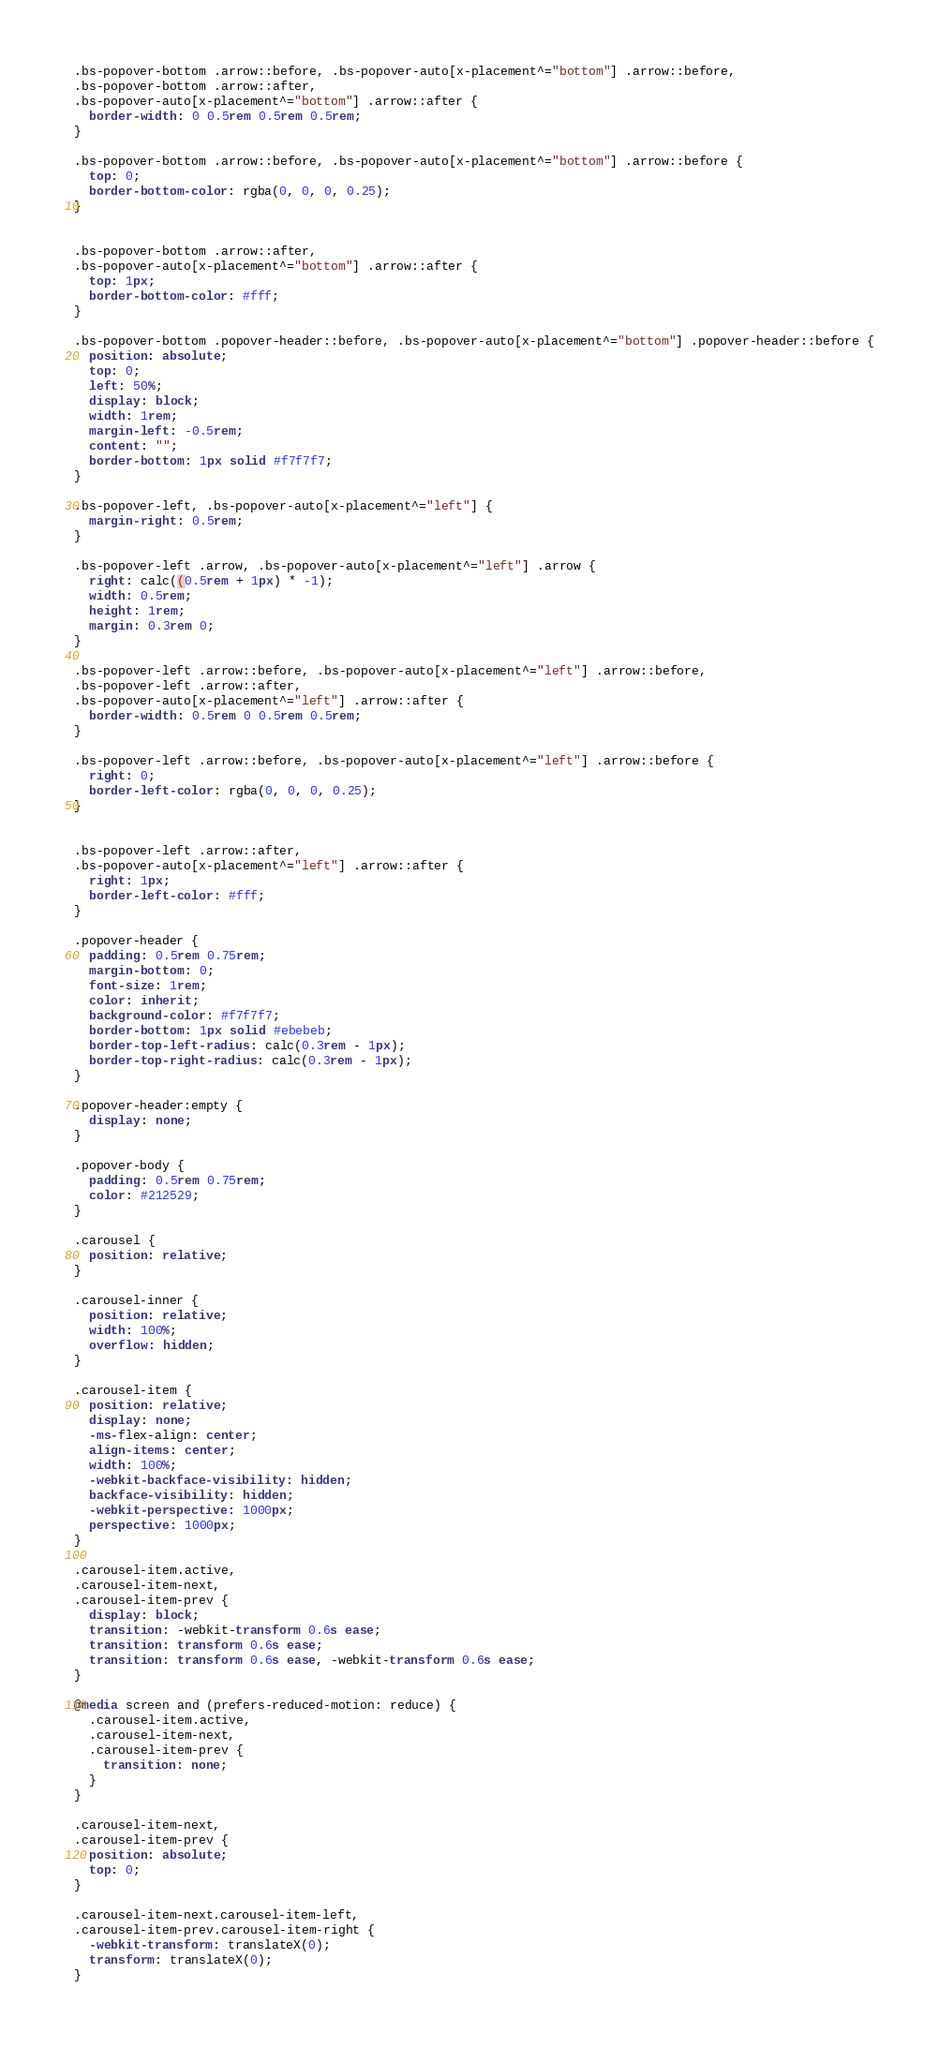Convert code to text. <code><loc_0><loc_0><loc_500><loc_500><_CSS_>
.bs-popover-bottom .arrow::before, .bs-popover-auto[x-placement^="bottom"] .arrow::before,
.bs-popover-bottom .arrow::after,
.bs-popover-auto[x-placement^="bottom"] .arrow::after {
  border-width: 0 0.5rem 0.5rem 0.5rem;
}

.bs-popover-bottom .arrow::before, .bs-popover-auto[x-placement^="bottom"] .arrow::before {
  top: 0;
  border-bottom-color: rgba(0, 0, 0, 0.25);
}


.bs-popover-bottom .arrow::after,
.bs-popover-auto[x-placement^="bottom"] .arrow::after {
  top: 1px;
  border-bottom-color: #fff;
}

.bs-popover-bottom .popover-header::before, .bs-popover-auto[x-placement^="bottom"] .popover-header::before {
  position: absolute;
  top: 0;
  left: 50%;
  display: block;
  width: 1rem;
  margin-left: -0.5rem;
  content: "";
  border-bottom: 1px solid #f7f7f7;
}

.bs-popover-left, .bs-popover-auto[x-placement^="left"] {
  margin-right: 0.5rem;
}

.bs-popover-left .arrow, .bs-popover-auto[x-placement^="left"] .arrow {
  right: calc((0.5rem + 1px) * -1);
  width: 0.5rem;
  height: 1rem;
  margin: 0.3rem 0;
}

.bs-popover-left .arrow::before, .bs-popover-auto[x-placement^="left"] .arrow::before,
.bs-popover-left .arrow::after,
.bs-popover-auto[x-placement^="left"] .arrow::after {
  border-width: 0.5rem 0 0.5rem 0.5rem;
}

.bs-popover-left .arrow::before, .bs-popover-auto[x-placement^="left"] .arrow::before {
  right: 0;
  border-left-color: rgba(0, 0, 0, 0.25);
}


.bs-popover-left .arrow::after,
.bs-popover-auto[x-placement^="left"] .arrow::after {
  right: 1px;
  border-left-color: #fff;
}

.popover-header {
  padding: 0.5rem 0.75rem;
  margin-bottom: 0;
  font-size: 1rem;
  color: inherit;
  background-color: #f7f7f7;
  border-bottom: 1px solid #ebebeb;
  border-top-left-radius: calc(0.3rem - 1px);
  border-top-right-radius: calc(0.3rem - 1px);
}

.popover-header:empty {
  display: none;
}

.popover-body {
  padding: 0.5rem 0.75rem;
  color: #212529;
}

.carousel {
  position: relative;
}

.carousel-inner {
  position: relative;
  width: 100%;
  overflow: hidden;
}

.carousel-item {
  position: relative;
  display: none;
  -ms-flex-align: center;
  align-items: center;
  width: 100%;
  -webkit-backface-visibility: hidden;
  backface-visibility: hidden;
  -webkit-perspective: 1000px;
  perspective: 1000px;
}

.carousel-item.active,
.carousel-item-next,
.carousel-item-prev {
  display: block;
  transition: -webkit-transform 0.6s ease;
  transition: transform 0.6s ease;
  transition: transform 0.6s ease, -webkit-transform 0.6s ease;
}

@media screen and (prefers-reduced-motion: reduce) {
  .carousel-item.active,
  .carousel-item-next,
  .carousel-item-prev {
    transition: none;
  }
}

.carousel-item-next,
.carousel-item-prev {
  position: absolute;
  top: 0;
}

.carousel-item-next.carousel-item-left,
.carousel-item-prev.carousel-item-right {
  -webkit-transform: translateX(0);
  transform: translateX(0);
}
</code> 